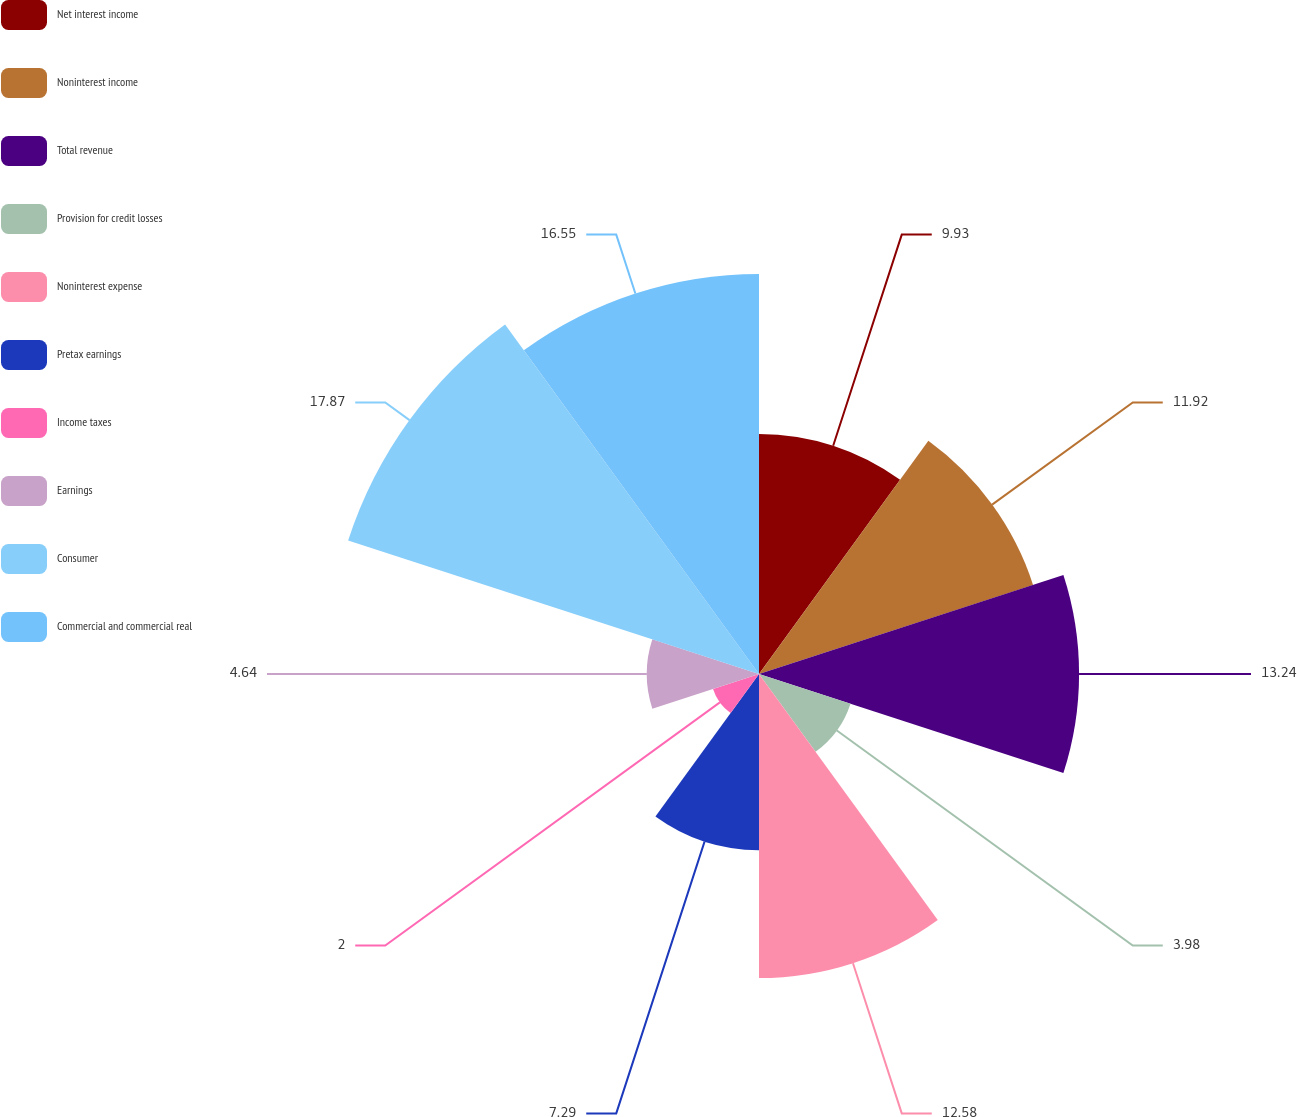<chart> <loc_0><loc_0><loc_500><loc_500><pie_chart><fcel>Net interest income<fcel>Noninterest income<fcel>Total revenue<fcel>Provision for credit losses<fcel>Noninterest expense<fcel>Pretax earnings<fcel>Income taxes<fcel>Earnings<fcel>Consumer<fcel>Commercial and commercial real<nl><fcel>9.93%<fcel>11.92%<fcel>13.24%<fcel>3.98%<fcel>12.58%<fcel>7.29%<fcel>2.0%<fcel>4.64%<fcel>17.87%<fcel>16.55%<nl></chart> 